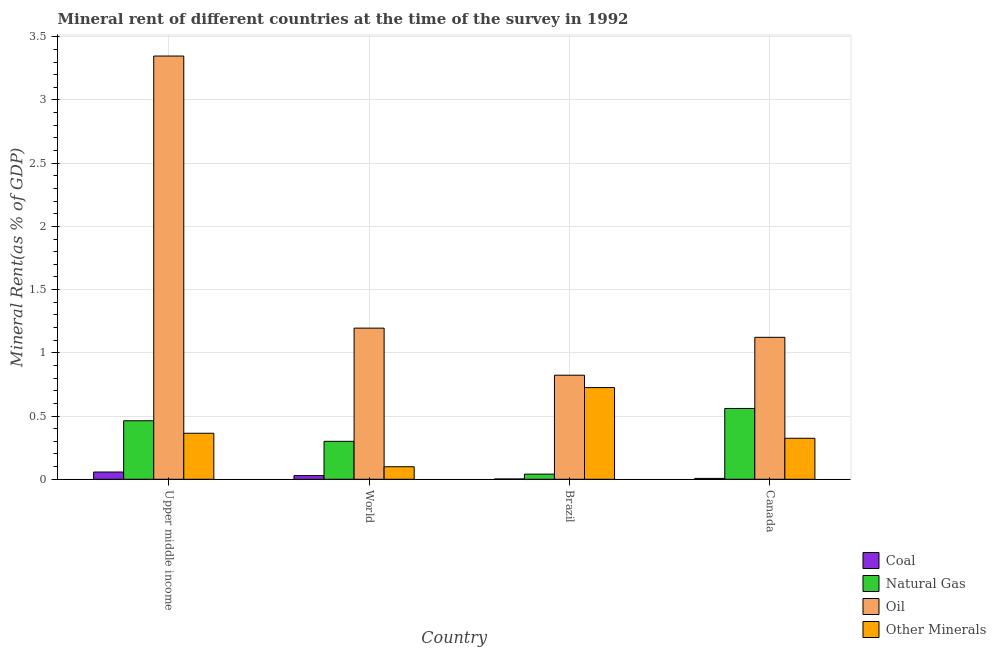How many different coloured bars are there?
Your answer should be very brief. 4. How many groups of bars are there?
Your answer should be compact. 4. Are the number of bars per tick equal to the number of legend labels?
Provide a short and direct response. Yes. Are the number of bars on each tick of the X-axis equal?
Make the answer very short. Yes. How many bars are there on the 4th tick from the left?
Keep it short and to the point. 4. How many bars are there on the 1st tick from the right?
Ensure brevity in your answer.  4. What is the label of the 3rd group of bars from the left?
Your answer should be compact. Brazil. What is the natural gas rent in Upper middle income?
Your response must be concise. 0.46. Across all countries, what is the maximum coal rent?
Offer a very short reply. 0.06. Across all countries, what is the minimum  rent of other minerals?
Your answer should be very brief. 0.1. In which country was the natural gas rent maximum?
Ensure brevity in your answer.  Canada. In which country was the  rent of other minerals minimum?
Provide a succinct answer. World. What is the total natural gas rent in the graph?
Your response must be concise. 1.36. What is the difference between the natural gas rent in Brazil and that in Upper middle income?
Make the answer very short. -0.42. What is the difference between the natural gas rent in Canada and the  rent of other minerals in Upper middle income?
Keep it short and to the point. 0.2. What is the average  rent of other minerals per country?
Provide a short and direct response. 0.38. What is the difference between the  rent of other minerals and natural gas rent in World?
Your answer should be very brief. -0.2. In how many countries, is the  rent of other minerals greater than 0.7 %?
Give a very brief answer. 1. What is the ratio of the oil rent in Brazil to that in World?
Make the answer very short. 0.69. Is the oil rent in Brazil less than that in Upper middle income?
Keep it short and to the point. Yes. Is the difference between the coal rent in Brazil and Upper middle income greater than the difference between the natural gas rent in Brazil and Upper middle income?
Offer a terse response. Yes. What is the difference between the highest and the second highest  rent of other minerals?
Provide a short and direct response. 0.36. What is the difference between the highest and the lowest natural gas rent?
Keep it short and to the point. 0.52. In how many countries, is the natural gas rent greater than the average natural gas rent taken over all countries?
Your answer should be compact. 2. Is it the case that in every country, the sum of the natural gas rent and coal rent is greater than the sum of oil rent and  rent of other minerals?
Offer a very short reply. No. What does the 2nd bar from the left in Brazil represents?
Ensure brevity in your answer.  Natural Gas. What does the 1st bar from the right in World represents?
Make the answer very short. Other Minerals. Are all the bars in the graph horizontal?
Offer a very short reply. No. How many countries are there in the graph?
Your answer should be very brief. 4. What is the difference between two consecutive major ticks on the Y-axis?
Provide a short and direct response. 0.5. Are the values on the major ticks of Y-axis written in scientific E-notation?
Your answer should be compact. No. Does the graph contain any zero values?
Your answer should be very brief. No. How many legend labels are there?
Offer a terse response. 4. What is the title of the graph?
Offer a very short reply. Mineral rent of different countries at the time of the survey in 1992. What is the label or title of the Y-axis?
Offer a very short reply. Mineral Rent(as % of GDP). What is the Mineral Rent(as % of GDP) of Coal in Upper middle income?
Give a very brief answer. 0.06. What is the Mineral Rent(as % of GDP) of Natural Gas in Upper middle income?
Your answer should be compact. 0.46. What is the Mineral Rent(as % of GDP) of Oil in Upper middle income?
Make the answer very short. 3.35. What is the Mineral Rent(as % of GDP) in Other Minerals in Upper middle income?
Your answer should be compact. 0.36. What is the Mineral Rent(as % of GDP) of Coal in World?
Your answer should be very brief. 0.03. What is the Mineral Rent(as % of GDP) in Natural Gas in World?
Offer a terse response. 0.3. What is the Mineral Rent(as % of GDP) in Oil in World?
Keep it short and to the point. 1.2. What is the Mineral Rent(as % of GDP) of Other Minerals in World?
Offer a very short reply. 0.1. What is the Mineral Rent(as % of GDP) in Coal in Brazil?
Ensure brevity in your answer.  0. What is the Mineral Rent(as % of GDP) in Natural Gas in Brazil?
Your answer should be compact. 0.04. What is the Mineral Rent(as % of GDP) in Oil in Brazil?
Keep it short and to the point. 0.82. What is the Mineral Rent(as % of GDP) in Other Minerals in Brazil?
Provide a succinct answer. 0.73. What is the Mineral Rent(as % of GDP) in Coal in Canada?
Offer a terse response. 0.01. What is the Mineral Rent(as % of GDP) in Natural Gas in Canada?
Offer a very short reply. 0.56. What is the Mineral Rent(as % of GDP) of Oil in Canada?
Your answer should be very brief. 1.12. What is the Mineral Rent(as % of GDP) in Other Minerals in Canada?
Give a very brief answer. 0.32. Across all countries, what is the maximum Mineral Rent(as % of GDP) in Coal?
Offer a terse response. 0.06. Across all countries, what is the maximum Mineral Rent(as % of GDP) in Natural Gas?
Offer a very short reply. 0.56. Across all countries, what is the maximum Mineral Rent(as % of GDP) in Oil?
Offer a terse response. 3.35. Across all countries, what is the maximum Mineral Rent(as % of GDP) in Other Minerals?
Your response must be concise. 0.73. Across all countries, what is the minimum Mineral Rent(as % of GDP) of Coal?
Offer a terse response. 0. Across all countries, what is the minimum Mineral Rent(as % of GDP) of Natural Gas?
Offer a terse response. 0.04. Across all countries, what is the minimum Mineral Rent(as % of GDP) of Oil?
Your answer should be very brief. 0.82. Across all countries, what is the minimum Mineral Rent(as % of GDP) of Other Minerals?
Provide a succinct answer. 0.1. What is the total Mineral Rent(as % of GDP) of Coal in the graph?
Provide a short and direct response. 0.1. What is the total Mineral Rent(as % of GDP) in Natural Gas in the graph?
Your answer should be very brief. 1.36. What is the total Mineral Rent(as % of GDP) in Oil in the graph?
Your answer should be compact. 6.49. What is the total Mineral Rent(as % of GDP) of Other Minerals in the graph?
Make the answer very short. 1.51. What is the difference between the Mineral Rent(as % of GDP) in Coal in Upper middle income and that in World?
Your response must be concise. 0.03. What is the difference between the Mineral Rent(as % of GDP) in Natural Gas in Upper middle income and that in World?
Provide a short and direct response. 0.16. What is the difference between the Mineral Rent(as % of GDP) in Oil in Upper middle income and that in World?
Provide a succinct answer. 2.15. What is the difference between the Mineral Rent(as % of GDP) in Other Minerals in Upper middle income and that in World?
Provide a short and direct response. 0.26. What is the difference between the Mineral Rent(as % of GDP) in Coal in Upper middle income and that in Brazil?
Make the answer very short. 0.06. What is the difference between the Mineral Rent(as % of GDP) of Natural Gas in Upper middle income and that in Brazil?
Keep it short and to the point. 0.42. What is the difference between the Mineral Rent(as % of GDP) in Oil in Upper middle income and that in Brazil?
Provide a short and direct response. 2.52. What is the difference between the Mineral Rent(as % of GDP) in Other Minerals in Upper middle income and that in Brazil?
Your answer should be compact. -0.36. What is the difference between the Mineral Rent(as % of GDP) of Coal in Upper middle income and that in Canada?
Make the answer very short. 0.05. What is the difference between the Mineral Rent(as % of GDP) in Natural Gas in Upper middle income and that in Canada?
Ensure brevity in your answer.  -0.1. What is the difference between the Mineral Rent(as % of GDP) of Oil in Upper middle income and that in Canada?
Provide a succinct answer. 2.22. What is the difference between the Mineral Rent(as % of GDP) in Other Minerals in Upper middle income and that in Canada?
Give a very brief answer. 0.04. What is the difference between the Mineral Rent(as % of GDP) of Coal in World and that in Brazil?
Offer a terse response. 0.03. What is the difference between the Mineral Rent(as % of GDP) of Natural Gas in World and that in Brazil?
Offer a terse response. 0.26. What is the difference between the Mineral Rent(as % of GDP) of Oil in World and that in Brazil?
Keep it short and to the point. 0.37. What is the difference between the Mineral Rent(as % of GDP) of Other Minerals in World and that in Brazil?
Provide a succinct answer. -0.63. What is the difference between the Mineral Rent(as % of GDP) in Coal in World and that in Canada?
Your answer should be very brief. 0.02. What is the difference between the Mineral Rent(as % of GDP) of Natural Gas in World and that in Canada?
Provide a succinct answer. -0.26. What is the difference between the Mineral Rent(as % of GDP) in Oil in World and that in Canada?
Make the answer very short. 0.07. What is the difference between the Mineral Rent(as % of GDP) of Other Minerals in World and that in Canada?
Your answer should be very brief. -0.23. What is the difference between the Mineral Rent(as % of GDP) in Coal in Brazil and that in Canada?
Offer a very short reply. -0. What is the difference between the Mineral Rent(as % of GDP) in Natural Gas in Brazil and that in Canada?
Offer a very short reply. -0.52. What is the difference between the Mineral Rent(as % of GDP) in Oil in Brazil and that in Canada?
Make the answer very short. -0.3. What is the difference between the Mineral Rent(as % of GDP) of Other Minerals in Brazil and that in Canada?
Give a very brief answer. 0.4. What is the difference between the Mineral Rent(as % of GDP) of Coal in Upper middle income and the Mineral Rent(as % of GDP) of Natural Gas in World?
Provide a succinct answer. -0.24. What is the difference between the Mineral Rent(as % of GDP) in Coal in Upper middle income and the Mineral Rent(as % of GDP) in Oil in World?
Provide a succinct answer. -1.14. What is the difference between the Mineral Rent(as % of GDP) in Coal in Upper middle income and the Mineral Rent(as % of GDP) in Other Minerals in World?
Your answer should be very brief. -0.04. What is the difference between the Mineral Rent(as % of GDP) in Natural Gas in Upper middle income and the Mineral Rent(as % of GDP) in Oil in World?
Give a very brief answer. -0.73. What is the difference between the Mineral Rent(as % of GDP) of Natural Gas in Upper middle income and the Mineral Rent(as % of GDP) of Other Minerals in World?
Provide a succinct answer. 0.36. What is the difference between the Mineral Rent(as % of GDP) of Oil in Upper middle income and the Mineral Rent(as % of GDP) of Other Minerals in World?
Your response must be concise. 3.25. What is the difference between the Mineral Rent(as % of GDP) in Coal in Upper middle income and the Mineral Rent(as % of GDP) in Natural Gas in Brazil?
Your answer should be very brief. 0.02. What is the difference between the Mineral Rent(as % of GDP) in Coal in Upper middle income and the Mineral Rent(as % of GDP) in Oil in Brazil?
Give a very brief answer. -0.77. What is the difference between the Mineral Rent(as % of GDP) of Coal in Upper middle income and the Mineral Rent(as % of GDP) of Other Minerals in Brazil?
Ensure brevity in your answer.  -0.67. What is the difference between the Mineral Rent(as % of GDP) in Natural Gas in Upper middle income and the Mineral Rent(as % of GDP) in Oil in Brazil?
Offer a very short reply. -0.36. What is the difference between the Mineral Rent(as % of GDP) in Natural Gas in Upper middle income and the Mineral Rent(as % of GDP) in Other Minerals in Brazil?
Your response must be concise. -0.26. What is the difference between the Mineral Rent(as % of GDP) in Oil in Upper middle income and the Mineral Rent(as % of GDP) in Other Minerals in Brazil?
Ensure brevity in your answer.  2.62. What is the difference between the Mineral Rent(as % of GDP) in Coal in Upper middle income and the Mineral Rent(as % of GDP) in Natural Gas in Canada?
Offer a very short reply. -0.5. What is the difference between the Mineral Rent(as % of GDP) of Coal in Upper middle income and the Mineral Rent(as % of GDP) of Oil in Canada?
Provide a succinct answer. -1.07. What is the difference between the Mineral Rent(as % of GDP) in Coal in Upper middle income and the Mineral Rent(as % of GDP) in Other Minerals in Canada?
Give a very brief answer. -0.27. What is the difference between the Mineral Rent(as % of GDP) in Natural Gas in Upper middle income and the Mineral Rent(as % of GDP) in Oil in Canada?
Give a very brief answer. -0.66. What is the difference between the Mineral Rent(as % of GDP) of Natural Gas in Upper middle income and the Mineral Rent(as % of GDP) of Other Minerals in Canada?
Make the answer very short. 0.14. What is the difference between the Mineral Rent(as % of GDP) of Oil in Upper middle income and the Mineral Rent(as % of GDP) of Other Minerals in Canada?
Keep it short and to the point. 3.02. What is the difference between the Mineral Rent(as % of GDP) of Coal in World and the Mineral Rent(as % of GDP) of Natural Gas in Brazil?
Make the answer very short. -0.01. What is the difference between the Mineral Rent(as % of GDP) of Coal in World and the Mineral Rent(as % of GDP) of Oil in Brazil?
Offer a terse response. -0.79. What is the difference between the Mineral Rent(as % of GDP) in Coal in World and the Mineral Rent(as % of GDP) in Other Minerals in Brazil?
Your answer should be compact. -0.7. What is the difference between the Mineral Rent(as % of GDP) of Natural Gas in World and the Mineral Rent(as % of GDP) of Oil in Brazil?
Provide a succinct answer. -0.52. What is the difference between the Mineral Rent(as % of GDP) of Natural Gas in World and the Mineral Rent(as % of GDP) of Other Minerals in Brazil?
Your response must be concise. -0.43. What is the difference between the Mineral Rent(as % of GDP) in Oil in World and the Mineral Rent(as % of GDP) in Other Minerals in Brazil?
Keep it short and to the point. 0.47. What is the difference between the Mineral Rent(as % of GDP) in Coal in World and the Mineral Rent(as % of GDP) in Natural Gas in Canada?
Keep it short and to the point. -0.53. What is the difference between the Mineral Rent(as % of GDP) in Coal in World and the Mineral Rent(as % of GDP) in Oil in Canada?
Your response must be concise. -1.09. What is the difference between the Mineral Rent(as % of GDP) in Coal in World and the Mineral Rent(as % of GDP) in Other Minerals in Canada?
Make the answer very short. -0.3. What is the difference between the Mineral Rent(as % of GDP) in Natural Gas in World and the Mineral Rent(as % of GDP) in Oil in Canada?
Ensure brevity in your answer.  -0.82. What is the difference between the Mineral Rent(as % of GDP) in Natural Gas in World and the Mineral Rent(as % of GDP) in Other Minerals in Canada?
Offer a very short reply. -0.02. What is the difference between the Mineral Rent(as % of GDP) in Oil in World and the Mineral Rent(as % of GDP) in Other Minerals in Canada?
Provide a short and direct response. 0.87. What is the difference between the Mineral Rent(as % of GDP) in Coal in Brazil and the Mineral Rent(as % of GDP) in Natural Gas in Canada?
Offer a very short reply. -0.56. What is the difference between the Mineral Rent(as % of GDP) in Coal in Brazil and the Mineral Rent(as % of GDP) in Oil in Canada?
Keep it short and to the point. -1.12. What is the difference between the Mineral Rent(as % of GDP) of Coal in Brazil and the Mineral Rent(as % of GDP) of Other Minerals in Canada?
Your response must be concise. -0.32. What is the difference between the Mineral Rent(as % of GDP) of Natural Gas in Brazil and the Mineral Rent(as % of GDP) of Oil in Canada?
Provide a short and direct response. -1.08. What is the difference between the Mineral Rent(as % of GDP) in Natural Gas in Brazil and the Mineral Rent(as % of GDP) in Other Minerals in Canada?
Give a very brief answer. -0.28. What is the difference between the Mineral Rent(as % of GDP) in Oil in Brazil and the Mineral Rent(as % of GDP) in Other Minerals in Canada?
Give a very brief answer. 0.5. What is the average Mineral Rent(as % of GDP) in Coal per country?
Your answer should be very brief. 0.02. What is the average Mineral Rent(as % of GDP) of Natural Gas per country?
Keep it short and to the point. 0.34. What is the average Mineral Rent(as % of GDP) of Oil per country?
Provide a succinct answer. 1.62. What is the average Mineral Rent(as % of GDP) in Other Minerals per country?
Give a very brief answer. 0.38. What is the difference between the Mineral Rent(as % of GDP) in Coal and Mineral Rent(as % of GDP) in Natural Gas in Upper middle income?
Your answer should be compact. -0.41. What is the difference between the Mineral Rent(as % of GDP) in Coal and Mineral Rent(as % of GDP) in Oil in Upper middle income?
Offer a very short reply. -3.29. What is the difference between the Mineral Rent(as % of GDP) of Coal and Mineral Rent(as % of GDP) of Other Minerals in Upper middle income?
Offer a terse response. -0.31. What is the difference between the Mineral Rent(as % of GDP) in Natural Gas and Mineral Rent(as % of GDP) in Oil in Upper middle income?
Provide a succinct answer. -2.88. What is the difference between the Mineral Rent(as % of GDP) in Natural Gas and Mineral Rent(as % of GDP) in Other Minerals in Upper middle income?
Offer a very short reply. 0.1. What is the difference between the Mineral Rent(as % of GDP) of Oil and Mineral Rent(as % of GDP) of Other Minerals in Upper middle income?
Provide a succinct answer. 2.98. What is the difference between the Mineral Rent(as % of GDP) in Coal and Mineral Rent(as % of GDP) in Natural Gas in World?
Provide a short and direct response. -0.27. What is the difference between the Mineral Rent(as % of GDP) of Coal and Mineral Rent(as % of GDP) of Oil in World?
Ensure brevity in your answer.  -1.17. What is the difference between the Mineral Rent(as % of GDP) of Coal and Mineral Rent(as % of GDP) of Other Minerals in World?
Provide a succinct answer. -0.07. What is the difference between the Mineral Rent(as % of GDP) in Natural Gas and Mineral Rent(as % of GDP) in Oil in World?
Provide a short and direct response. -0.9. What is the difference between the Mineral Rent(as % of GDP) in Natural Gas and Mineral Rent(as % of GDP) in Other Minerals in World?
Ensure brevity in your answer.  0.2. What is the difference between the Mineral Rent(as % of GDP) of Oil and Mineral Rent(as % of GDP) of Other Minerals in World?
Make the answer very short. 1.1. What is the difference between the Mineral Rent(as % of GDP) of Coal and Mineral Rent(as % of GDP) of Natural Gas in Brazil?
Offer a terse response. -0.04. What is the difference between the Mineral Rent(as % of GDP) of Coal and Mineral Rent(as % of GDP) of Oil in Brazil?
Give a very brief answer. -0.82. What is the difference between the Mineral Rent(as % of GDP) of Coal and Mineral Rent(as % of GDP) of Other Minerals in Brazil?
Make the answer very short. -0.72. What is the difference between the Mineral Rent(as % of GDP) in Natural Gas and Mineral Rent(as % of GDP) in Oil in Brazil?
Provide a short and direct response. -0.78. What is the difference between the Mineral Rent(as % of GDP) in Natural Gas and Mineral Rent(as % of GDP) in Other Minerals in Brazil?
Provide a succinct answer. -0.68. What is the difference between the Mineral Rent(as % of GDP) in Oil and Mineral Rent(as % of GDP) in Other Minerals in Brazil?
Your answer should be compact. 0.1. What is the difference between the Mineral Rent(as % of GDP) in Coal and Mineral Rent(as % of GDP) in Natural Gas in Canada?
Offer a terse response. -0.55. What is the difference between the Mineral Rent(as % of GDP) in Coal and Mineral Rent(as % of GDP) in Oil in Canada?
Keep it short and to the point. -1.12. What is the difference between the Mineral Rent(as % of GDP) in Coal and Mineral Rent(as % of GDP) in Other Minerals in Canada?
Make the answer very short. -0.32. What is the difference between the Mineral Rent(as % of GDP) of Natural Gas and Mineral Rent(as % of GDP) of Oil in Canada?
Your answer should be compact. -0.56. What is the difference between the Mineral Rent(as % of GDP) of Natural Gas and Mineral Rent(as % of GDP) of Other Minerals in Canada?
Keep it short and to the point. 0.24. What is the difference between the Mineral Rent(as % of GDP) in Oil and Mineral Rent(as % of GDP) in Other Minerals in Canada?
Your answer should be very brief. 0.8. What is the ratio of the Mineral Rent(as % of GDP) of Coal in Upper middle income to that in World?
Give a very brief answer. 1.98. What is the ratio of the Mineral Rent(as % of GDP) in Natural Gas in Upper middle income to that in World?
Make the answer very short. 1.54. What is the ratio of the Mineral Rent(as % of GDP) of Oil in Upper middle income to that in World?
Offer a terse response. 2.8. What is the ratio of the Mineral Rent(as % of GDP) in Other Minerals in Upper middle income to that in World?
Your response must be concise. 3.67. What is the ratio of the Mineral Rent(as % of GDP) in Coal in Upper middle income to that in Brazil?
Your response must be concise. 24.99. What is the ratio of the Mineral Rent(as % of GDP) of Natural Gas in Upper middle income to that in Brazil?
Your response must be concise. 11.38. What is the ratio of the Mineral Rent(as % of GDP) of Oil in Upper middle income to that in Brazil?
Keep it short and to the point. 4.07. What is the ratio of the Mineral Rent(as % of GDP) of Other Minerals in Upper middle income to that in Brazil?
Provide a short and direct response. 0.5. What is the ratio of the Mineral Rent(as % of GDP) of Coal in Upper middle income to that in Canada?
Provide a short and direct response. 8.35. What is the ratio of the Mineral Rent(as % of GDP) in Natural Gas in Upper middle income to that in Canada?
Your answer should be very brief. 0.83. What is the ratio of the Mineral Rent(as % of GDP) in Oil in Upper middle income to that in Canada?
Provide a short and direct response. 2.98. What is the ratio of the Mineral Rent(as % of GDP) in Other Minerals in Upper middle income to that in Canada?
Offer a very short reply. 1.12. What is the ratio of the Mineral Rent(as % of GDP) in Coal in World to that in Brazil?
Keep it short and to the point. 12.59. What is the ratio of the Mineral Rent(as % of GDP) of Natural Gas in World to that in Brazil?
Keep it short and to the point. 7.38. What is the ratio of the Mineral Rent(as % of GDP) in Oil in World to that in Brazil?
Keep it short and to the point. 1.45. What is the ratio of the Mineral Rent(as % of GDP) of Other Minerals in World to that in Brazil?
Provide a succinct answer. 0.14. What is the ratio of the Mineral Rent(as % of GDP) in Coal in World to that in Canada?
Ensure brevity in your answer.  4.21. What is the ratio of the Mineral Rent(as % of GDP) of Natural Gas in World to that in Canada?
Your answer should be compact. 0.54. What is the ratio of the Mineral Rent(as % of GDP) of Oil in World to that in Canada?
Your answer should be compact. 1.06. What is the ratio of the Mineral Rent(as % of GDP) of Other Minerals in World to that in Canada?
Provide a short and direct response. 0.31. What is the ratio of the Mineral Rent(as % of GDP) of Coal in Brazil to that in Canada?
Offer a very short reply. 0.33. What is the ratio of the Mineral Rent(as % of GDP) in Natural Gas in Brazil to that in Canada?
Offer a very short reply. 0.07. What is the ratio of the Mineral Rent(as % of GDP) of Oil in Brazil to that in Canada?
Your response must be concise. 0.73. What is the ratio of the Mineral Rent(as % of GDP) of Other Minerals in Brazil to that in Canada?
Provide a short and direct response. 2.24. What is the difference between the highest and the second highest Mineral Rent(as % of GDP) of Coal?
Your answer should be very brief. 0.03. What is the difference between the highest and the second highest Mineral Rent(as % of GDP) in Natural Gas?
Make the answer very short. 0.1. What is the difference between the highest and the second highest Mineral Rent(as % of GDP) in Oil?
Offer a very short reply. 2.15. What is the difference between the highest and the second highest Mineral Rent(as % of GDP) of Other Minerals?
Provide a short and direct response. 0.36. What is the difference between the highest and the lowest Mineral Rent(as % of GDP) of Coal?
Give a very brief answer. 0.06. What is the difference between the highest and the lowest Mineral Rent(as % of GDP) in Natural Gas?
Provide a succinct answer. 0.52. What is the difference between the highest and the lowest Mineral Rent(as % of GDP) of Oil?
Offer a very short reply. 2.52. What is the difference between the highest and the lowest Mineral Rent(as % of GDP) of Other Minerals?
Your answer should be very brief. 0.63. 